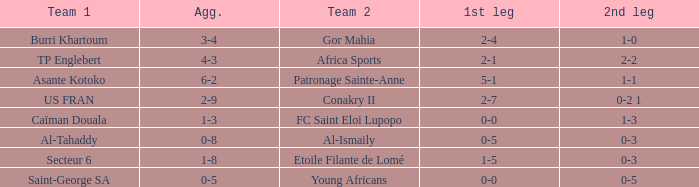What was the 2nd leg score between Patronage Sainte-Anne and Asante Kotoko? 1-1. 